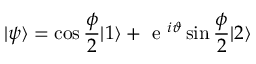Convert formula to latex. <formula><loc_0><loc_0><loc_500><loc_500>| \psi \rangle = \cos \frac { \phi } { 2 } | 1 \rangle + e ^ { i \vartheta } \sin \frac { \phi } { 2 } | 2 \rangle</formula> 